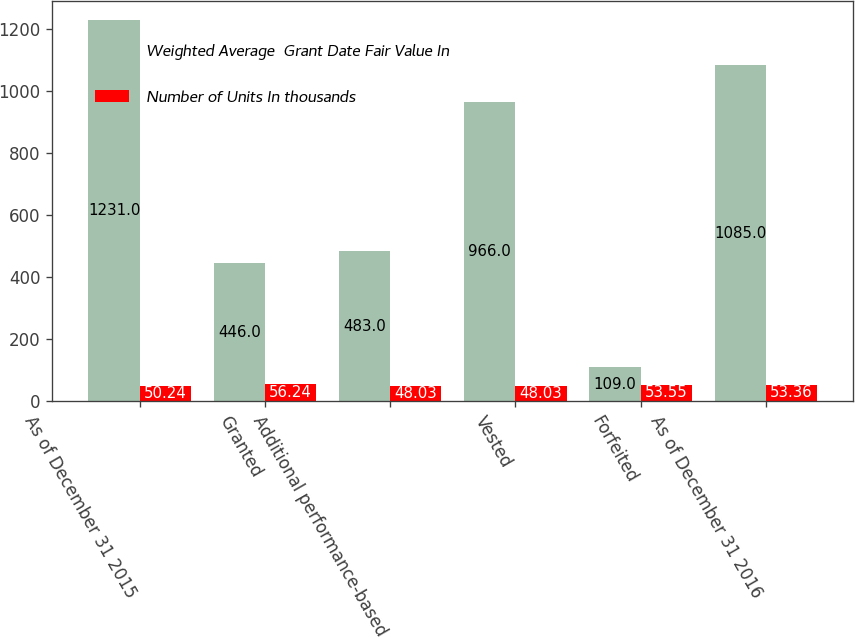Convert chart to OTSL. <chart><loc_0><loc_0><loc_500><loc_500><stacked_bar_chart><ecel><fcel>As of December 31 2015<fcel>Granted<fcel>Additional performance-based<fcel>Vested<fcel>Forfeited<fcel>As of December 31 2016<nl><fcel>Weighted Average  Grant Date Fair Value In<fcel>1231<fcel>446<fcel>483<fcel>966<fcel>109<fcel>1085<nl><fcel>Number of Units In thousands<fcel>50.24<fcel>56.24<fcel>48.03<fcel>48.03<fcel>53.55<fcel>53.36<nl></chart> 